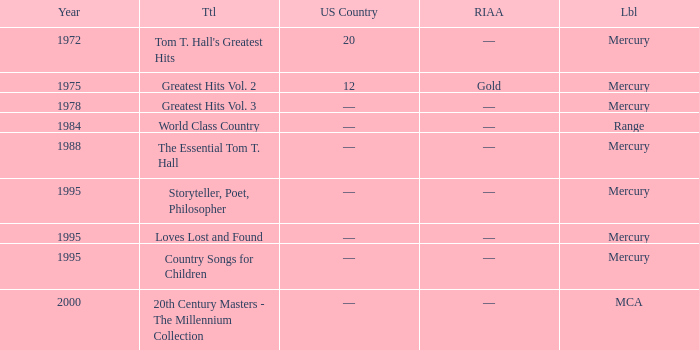What label had the album after 1978? Range, Mercury, Mercury, Mercury, Mercury, MCA. 